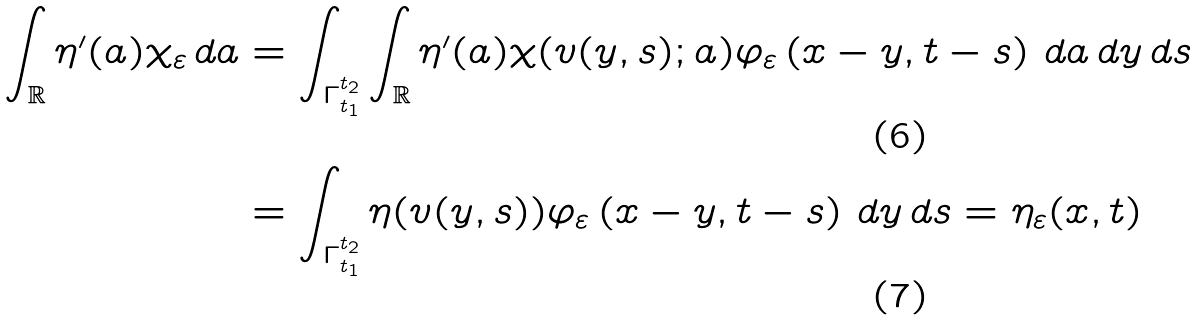<formula> <loc_0><loc_0><loc_500><loc_500>\int _ { \mathbb { R } } \eta ^ { \prime } ( a ) \chi _ { \varepsilon } \, d a & = \int _ { \Gamma _ { t _ { 1 } } ^ { t _ { 2 } } } \int _ { \mathbb { R } } \eta ^ { \prime } ( a ) \chi ( v ( y , s ) ; a ) \varphi _ { \varepsilon } \left ( x - y , t - s \right ) \, d a \, d y \, d s \\ & = \int _ { \Gamma _ { t _ { 1 } } ^ { t _ { 2 } } } \eta ( v ( y , s ) ) \varphi _ { \varepsilon } \left ( x - y , t - s \right ) \, d y \, d s = \eta _ { \varepsilon } ( x , t )</formula> 